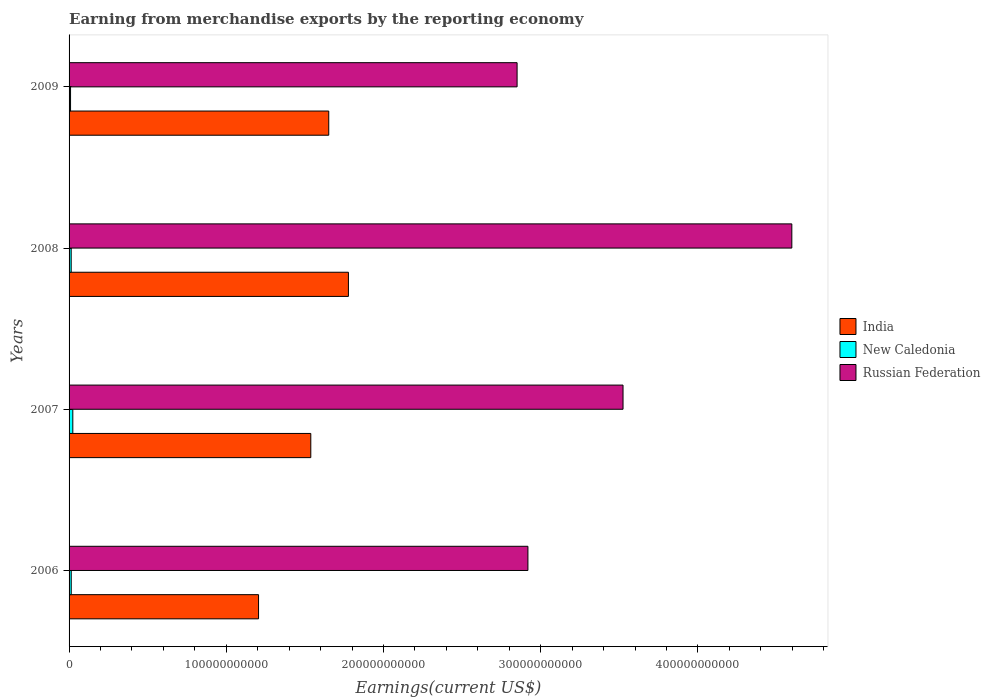How many bars are there on the 2nd tick from the top?
Offer a very short reply. 3. How many bars are there on the 3rd tick from the bottom?
Keep it short and to the point. 3. What is the amount earned from merchandise exports in New Caledonia in 2008?
Provide a short and direct response. 1.34e+09. Across all years, what is the maximum amount earned from merchandise exports in Russian Federation?
Provide a short and direct response. 4.60e+11. Across all years, what is the minimum amount earned from merchandise exports in Russian Federation?
Provide a succinct answer. 2.85e+11. In which year was the amount earned from merchandise exports in New Caledonia maximum?
Your answer should be compact. 2007. In which year was the amount earned from merchandise exports in Russian Federation minimum?
Provide a succinct answer. 2009. What is the total amount earned from merchandise exports in India in the graph?
Your answer should be very brief. 6.17e+11. What is the difference between the amount earned from merchandise exports in New Caledonia in 2006 and that in 2009?
Your answer should be very brief. 4.35e+08. What is the difference between the amount earned from merchandise exports in New Caledonia in 2006 and the amount earned from merchandise exports in India in 2009?
Provide a short and direct response. -1.64e+11. What is the average amount earned from merchandise exports in New Caledonia per year?
Ensure brevity in your answer.  1.51e+09. In the year 2008, what is the difference between the amount earned from merchandise exports in Russian Federation and amount earned from merchandise exports in India?
Your response must be concise. 2.82e+11. What is the ratio of the amount earned from merchandise exports in New Caledonia in 2007 to that in 2009?
Give a very brief answer. 2.52. What is the difference between the highest and the second highest amount earned from merchandise exports in New Caledonia?
Provide a succinct answer. 1.00e+09. What is the difference between the highest and the lowest amount earned from merchandise exports in India?
Your answer should be very brief. 5.72e+1. Is the sum of the amount earned from merchandise exports in Russian Federation in 2006 and 2008 greater than the maximum amount earned from merchandise exports in New Caledonia across all years?
Provide a succinct answer. Yes. What is the difference between two consecutive major ticks on the X-axis?
Your response must be concise. 1.00e+11. Are the values on the major ticks of X-axis written in scientific E-notation?
Your answer should be very brief. No. Does the graph contain grids?
Provide a short and direct response. No. How are the legend labels stacked?
Provide a short and direct response. Vertical. What is the title of the graph?
Offer a terse response. Earning from merchandise exports by the reporting economy. What is the label or title of the X-axis?
Your answer should be compact. Earnings(current US$). What is the label or title of the Y-axis?
Your response must be concise. Years. What is the Earnings(current US$) of India in 2006?
Provide a short and direct response. 1.21e+11. What is the Earnings(current US$) of New Caledonia in 2006?
Keep it short and to the point. 1.38e+09. What is the Earnings(current US$) in Russian Federation in 2006?
Offer a terse response. 2.92e+11. What is the Earnings(current US$) in India in 2007?
Ensure brevity in your answer.  1.54e+11. What is the Earnings(current US$) in New Caledonia in 2007?
Your answer should be compact. 2.38e+09. What is the Earnings(current US$) in Russian Federation in 2007?
Your answer should be compact. 3.52e+11. What is the Earnings(current US$) in India in 2008?
Your response must be concise. 1.78e+11. What is the Earnings(current US$) of New Caledonia in 2008?
Your response must be concise. 1.34e+09. What is the Earnings(current US$) in Russian Federation in 2008?
Your answer should be compact. 4.60e+11. What is the Earnings(current US$) of India in 2009?
Offer a very short reply. 1.65e+11. What is the Earnings(current US$) in New Caledonia in 2009?
Provide a succinct answer. 9.41e+08. What is the Earnings(current US$) of Russian Federation in 2009?
Your answer should be compact. 2.85e+11. Across all years, what is the maximum Earnings(current US$) in India?
Give a very brief answer. 1.78e+11. Across all years, what is the maximum Earnings(current US$) of New Caledonia?
Keep it short and to the point. 2.38e+09. Across all years, what is the maximum Earnings(current US$) in Russian Federation?
Your response must be concise. 4.60e+11. Across all years, what is the minimum Earnings(current US$) in India?
Offer a very short reply. 1.21e+11. Across all years, what is the minimum Earnings(current US$) in New Caledonia?
Give a very brief answer. 9.41e+08. Across all years, what is the minimum Earnings(current US$) in Russian Federation?
Your response must be concise. 2.85e+11. What is the total Earnings(current US$) in India in the graph?
Give a very brief answer. 6.17e+11. What is the total Earnings(current US$) of New Caledonia in the graph?
Keep it short and to the point. 6.04e+09. What is the total Earnings(current US$) of Russian Federation in the graph?
Your answer should be compact. 1.39e+12. What is the difference between the Earnings(current US$) of India in 2006 and that in 2007?
Offer a very short reply. -3.32e+1. What is the difference between the Earnings(current US$) of New Caledonia in 2006 and that in 2007?
Give a very brief answer. -1.00e+09. What is the difference between the Earnings(current US$) of Russian Federation in 2006 and that in 2007?
Your answer should be very brief. -6.05e+1. What is the difference between the Earnings(current US$) of India in 2006 and that in 2008?
Offer a very short reply. -5.72e+1. What is the difference between the Earnings(current US$) of New Caledonia in 2006 and that in 2008?
Provide a succinct answer. 3.35e+07. What is the difference between the Earnings(current US$) of Russian Federation in 2006 and that in 2008?
Provide a short and direct response. -1.68e+11. What is the difference between the Earnings(current US$) of India in 2006 and that in 2009?
Ensure brevity in your answer.  -4.47e+1. What is the difference between the Earnings(current US$) of New Caledonia in 2006 and that in 2009?
Ensure brevity in your answer.  4.35e+08. What is the difference between the Earnings(current US$) of Russian Federation in 2006 and that in 2009?
Give a very brief answer. 6.89e+09. What is the difference between the Earnings(current US$) of India in 2007 and that in 2008?
Keep it short and to the point. -2.39e+1. What is the difference between the Earnings(current US$) of New Caledonia in 2007 and that in 2008?
Ensure brevity in your answer.  1.03e+09. What is the difference between the Earnings(current US$) in Russian Federation in 2007 and that in 2008?
Offer a terse response. -1.07e+11. What is the difference between the Earnings(current US$) of India in 2007 and that in 2009?
Offer a terse response. -1.14e+1. What is the difference between the Earnings(current US$) in New Caledonia in 2007 and that in 2009?
Your answer should be compact. 1.43e+09. What is the difference between the Earnings(current US$) in Russian Federation in 2007 and that in 2009?
Ensure brevity in your answer.  6.74e+1. What is the difference between the Earnings(current US$) of India in 2008 and that in 2009?
Provide a succinct answer. 1.25e+1. What is the difference between the Earnings(current US$) in New Caledonia in 2008 and that in 2009?
Your answer should be very brief. 4.02e+08. What is the difference between the Earnings(current US$) in Russian Federation in 2008 and that in 2009?
Your answer should be very brief. 1.75e+11. What is the difference between the Earnings(current US$) in India in 2006 and the Earnings(current US$) in New Caledonia in 2007?
Offer a very short reply. 1.18e+11. What is the difference between the Earnings(current US$) of India in 2006 and the Earnings(current US$) of Russian Federation in 2007?
Make the answer very short. -2.32e+11. What is the difference between the Earnings(current US$) of New Caledonia in 2006 and the Earnings(current US$) of Russian Federation in 2007?
Keep it short and to the point. -3.51e+11. What is the difference between the Earnings(current US$) of India in 2006 and the Earnings(current US$) of New Caledonia in 2008?
Your answer should be very brief. 1.19e+11. What is the difference between the Earnings(current US$) of India in 2006 and the Earnings(current US$) of Russian Federation in 2008?
Provide a succinct answer. -3.39e+11. What is the difference between the Earnings(current US$) in New Caledonia in 2006 and the Earnings(current US$) in Russian Federation in 2008?
Your answer should be very brief. -4.58e+11. What is the difference between the Earnings(current US$) in India in 2006 and the Earnings(current US$) in New Caledonia in 2009?
Ensure brevity in your answer.  1.20e+11. What is the difference between the Earnings(current US$) in India in 2006 and the Earnings(current US$) in Russian Federation in 2009?
Make the answer very short. -1.64e+11. What is the difference between the Earnings(current US$) of New Caledonia in 2006 and the Earnings(current US$) of Russian Federation in 2009?
Provide a short and direct response. -2.84e+11. What is the difference between the Earnings(current US$) of India in 2007 and the Earnings(current US$) of New Caledonia in 2008?
Your response must be concise. 1.52e+11. What is the difference between the Earnings(current US$) in India in 2007 and the Earnings(current US$) in Russian Federation in 2008?
Keep it short and to the point. -3.06e+11. What is the difference between the Earnings(current US$) in New Caledonia in 2007 and the Earnings(current US$) in Russian Federation in 2008?
Provide a succinct answer. -4.57e+11. What is the difference between the Earnings(current US$) of India in 2007 and the Earnings(current US$) of New Caledonia in 2009?
Ensure brevity in your answer.  1.53e+11. What is the difference between the Earnings(current US$) of India in 2007 and the Earnings(current US$) of Russian Federation in 2009?
Provide a succinct answer. -1.31e+11. What is the difference between the Earnings(current US$) in New Caledonia in 2007 and the Earnings(current US$) in Russian Federation in 2009?
Offer a very short reply. -2.83e+11. What is the difference between the Earnings(current US$) of India in 2008 and the Earnings(current US$) of New Caledonia in 2009?
Provide a short and direct response. 1.77e+11. What is the difference between the Earnings(current US$) in India in 2008 and the Earnings(current US$) in Russian Federation in 2009?
Offer a very short reply. -1.07e+11. What is the difference between the Earnings(current US$) in New Caledonia in 2008 and the Earnings(current US$) in Russian Federation in 2009?
Offer a terse response. -2.84e+11. What is the average Earnings(current US$) in India per year?
Your answer should be very brief. 1.54e+11. What is the average Earnings(current US$) in New Caledonia per year?
Offer a very short reply. 1.51e+09. What is the average Earnings(current US$) of Russian Federation per year?
Make the answer very short. 3.47e+11. In the year 2006, what is the difference between the Earnings(current US$) of India and Earnings(current US$) of New Caledonia?
Keep it short and to the point. 1.19e+11. In the year 2006, what is the difference between the Earnings(current US$) in India and Earnings(current US$) in Russian Federation?
Provide a succinct answer. -1.71e+11. In the year 2006, what is the difference between the Earnings(current US$) in New Caledonia and Earnings(current US$) in Russian Federation?
Your answer should be compact. -2.91e+11. In the year 2007, what is the difference between the Earnings(current US$) of India and Earnings(current US$) of New Caledonia?
Offer a very short reply. 1.51e+11. In the year 2007, what is the difference between the Earnings(current US$) of India and Earnings(current US$) of Russian Federation?
Your answer should be very brief. -1.99e+11. In the year 2007, what is the difference between the Earnings(current US$) of New Caledonia and Earnings(current US$) of Russian Federation?
Your response must be concise. -3.50e+11. In the year 2008, what is the difference between the Earnings(current US$) in India and Earnings(current US$) in New Caledonia?
Offer a terse response. 1.76e+11. In the year 2008, what is the difference between the Earnings(current US$) in India and Earnings(current US$) in Russian Federation?
Your response must be concise. -2.82e+11. In the year 2008, what is the difference between the Earnings(current US$) of New Caledonia and Earnings(current US$) of Russian Federation?
Provide a succinct answer. -4.58e+11. In the year 2009, what is the difference between the Earnings(current US$) in India and Earnings(current US$) in New Caledonia?
Make the answer very short. 1.64e+11. In the year 2009, what is the difference between the Earnings(current US$) in India and Earnings(current US$) in Russian Federation?
Provide a short and direct response. -1.20e+11. In the year 2009, what is the difference between the Earnings(current US$) in New Caledonia and Earnings(current US$) in Russian Federation?
Your response must be concise. -2.84e+11. What is the ratio of the Earnings(current US$) of India in 2006 to that in 2007?
Give a very brief answer. 0.78. What is the ratio of the Earnings(current US$) in New Caledonia in 2006 to that in 2007?
Provide a succinct answer. 0.58. What is the ratio of the Earnings(current US$) of Russian Federation in 2006 to that in 2007?
Make the answer very short. 0.83. What is the ratio of the Earnings(current US$) in India in 2006 to that in 2008?
Your response must be concise. 0.68. What is the ratio of the Earnings(current US$) in New Caledonia in 2006 to that in 2008?
Provide a succinct answer. 1.02. What is the ratio of the Earnings(current US$) in Russian Federation in 2006 to that in 2008?
Provide a short and direct response. 0.63. What is the ratio of the Earnings(current US$) of India in 2006 to that in 2009?
Your answer should be very brief. 0.73. What is the ratio of the Earnings(current US$) in New Caledonia in 2006 to that in 2009?
Ensure brevity in your answer.  1.46. What is the ratio of the Earnings(current US$) of Russian Federation in 2006 to that in 2009?
Provide a short and direct response. 1.02. What is the ratio of the Earnings(current US$) in India in 2007 to that in 2008?
Provide a succinct answer. 0.87. What is the ratio of the Earnings(current US$) of New Caledonia in 2007 to that in 2008?
Your response must be concise. 1.77. What is the ratio of the Earnings(current US$) of Russian Federation in 2007 to that in 2008?
Offer a very short reply. 0.77. What is the ratio of the Earnings(current US$) of India in 2007 to that in 2009?
Offer a terse response. 0.93. What is the ratio of the Earnings(current US$) in New Caledonia in 2007 to that in 2009?
Offer a terse response. 2.52. What is the ratio of the Earnings(current US$) of Russian Federation in 2007 to that in 2009?
Ensure brevity in your answer.  1.24. What is the ratio of the Earnings(current US$) in India in 2008 to that in 2009?
Give a very brief answer. 1.08. What is the ratio of the Earnings(current US$) of New Caledonia in 2008 to that in 2009?
Ensure brevity in your answer.  1.43. What is the ratio of the Earnings(current US$) in Russian Federation in 2008 to that in 2009?
Provide a short and direct response. 1.61. What is the difference between the highest and the second highest Earnings(current US$) in India?
Keep it short and to the point. 1.25e+1. What is the difference between the highest and the second highest Earnings(current US$) of New Caledonia?
Provide a short and direct response. 1.00e+09. What is the difference between the highest and the second highest Earnings(current US$) of Russian Federation?
Provide a succinct answer. 1.07e+11. What is the difference between the highest and the lowest Earnings(current US$) of India?
Make the answer very short. 5.72e+1. What is the difference between the highest and the lowest Earnings(current US$) of New Caledonia?
Make the answer very short. 1.43e+09. What is the difference between the highest and the lowest Earnings(current US$) of Russian Federation?
Give a very brief answer. 1.75e+11. 